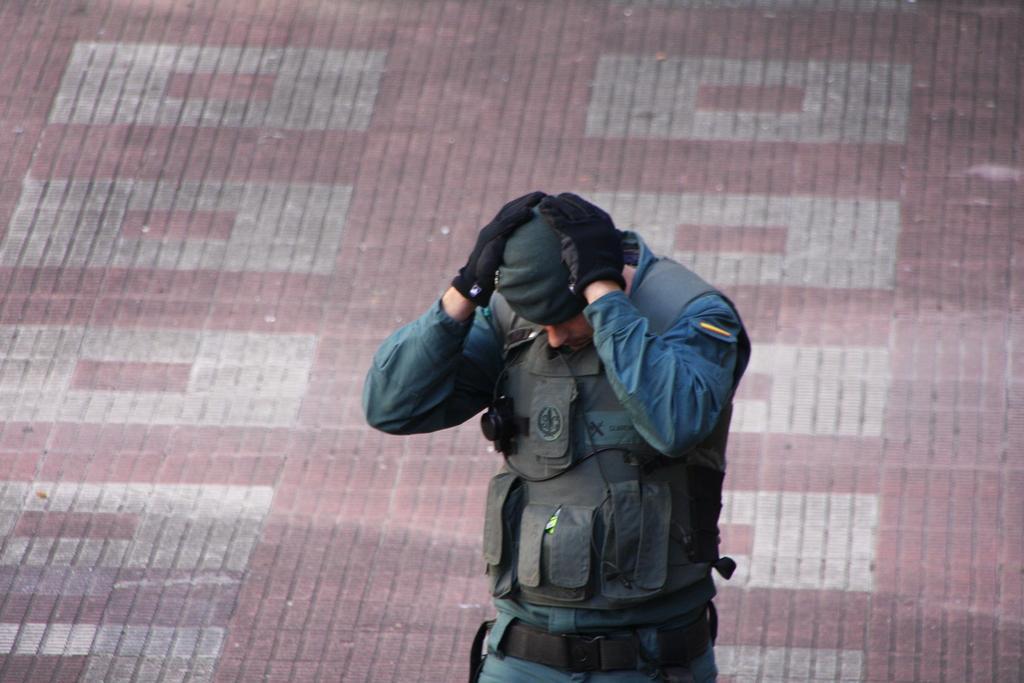In one or two sentences, can you explain what this image depicts? In this picture there is a man who is standing in the center of the image, by placing his hands on the head. 